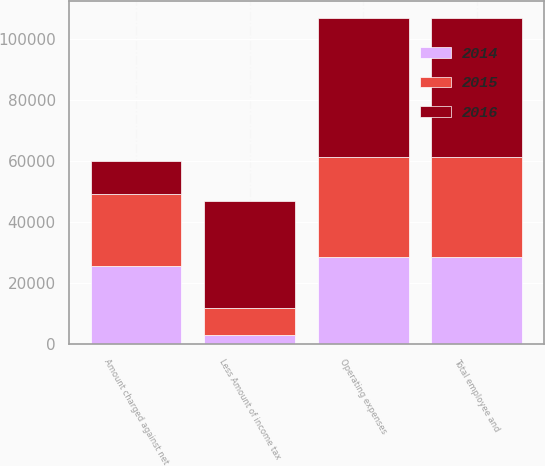Convert chart to OTSL. <chart><loc_0><loc_0><loc_500><loc_500><stacked_bar_chart><ecel><fcel>Operating expenses<fcel>Total employee and<fcel>Less Amount of income tax<fcel>Amount charged against net<nl><fcel>2016<fcel>45848<fcel>45848<fcel>34909<fcel>10939<nl><fcel>2015<fcel>32719<fcel>32719<fcel>9058<fcel>23661<nl><fcel>2014<fcel>28552<fcel>28552<fcel>2932<fcel>25620<nl></chart> 